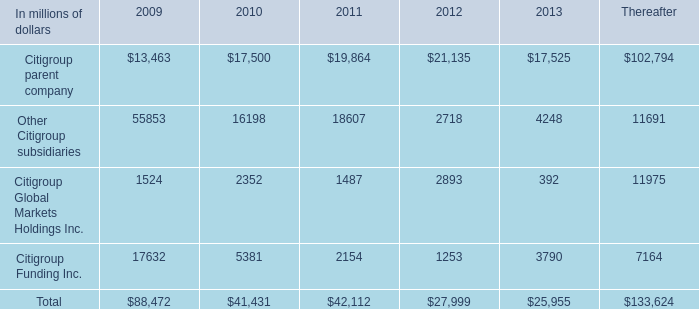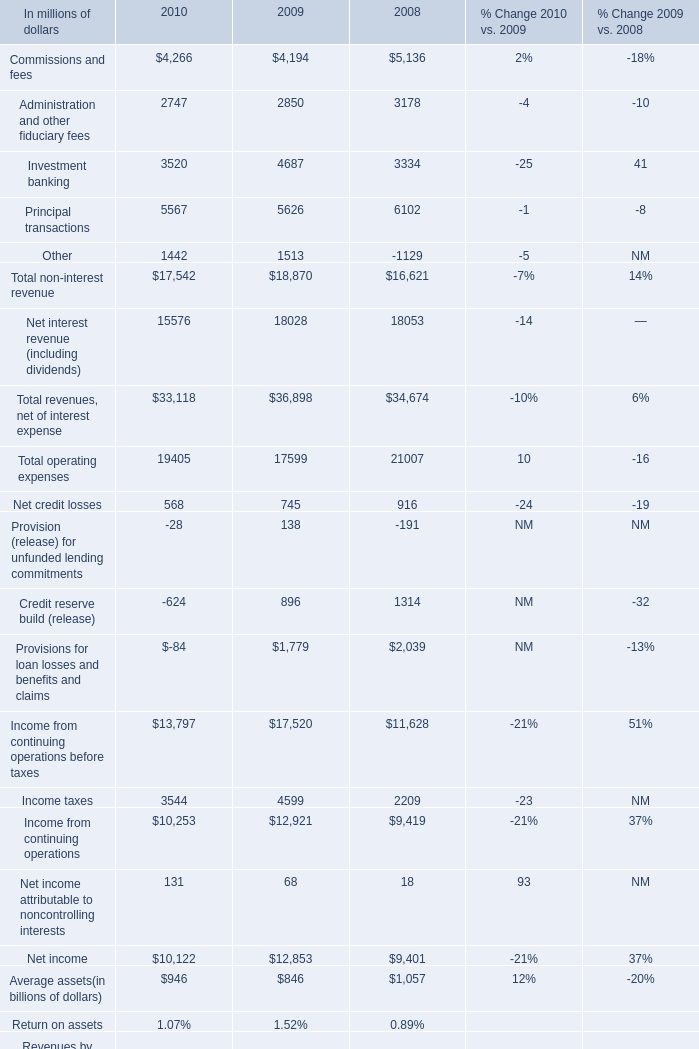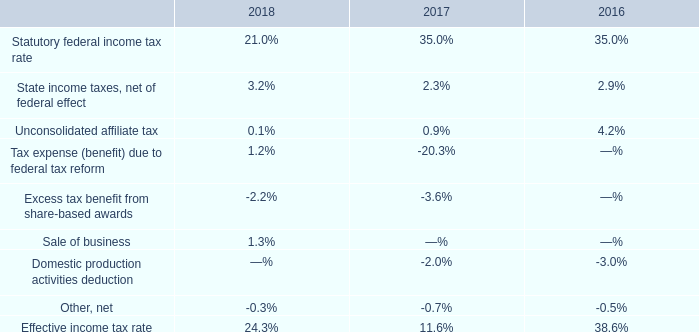What's the average of Other Citigroup subsidiaries of 2010, and Income taxes of 2010 ? 
Computations: ((16198.0 + 3544.0) / 2)
Answer: 9871.0. 